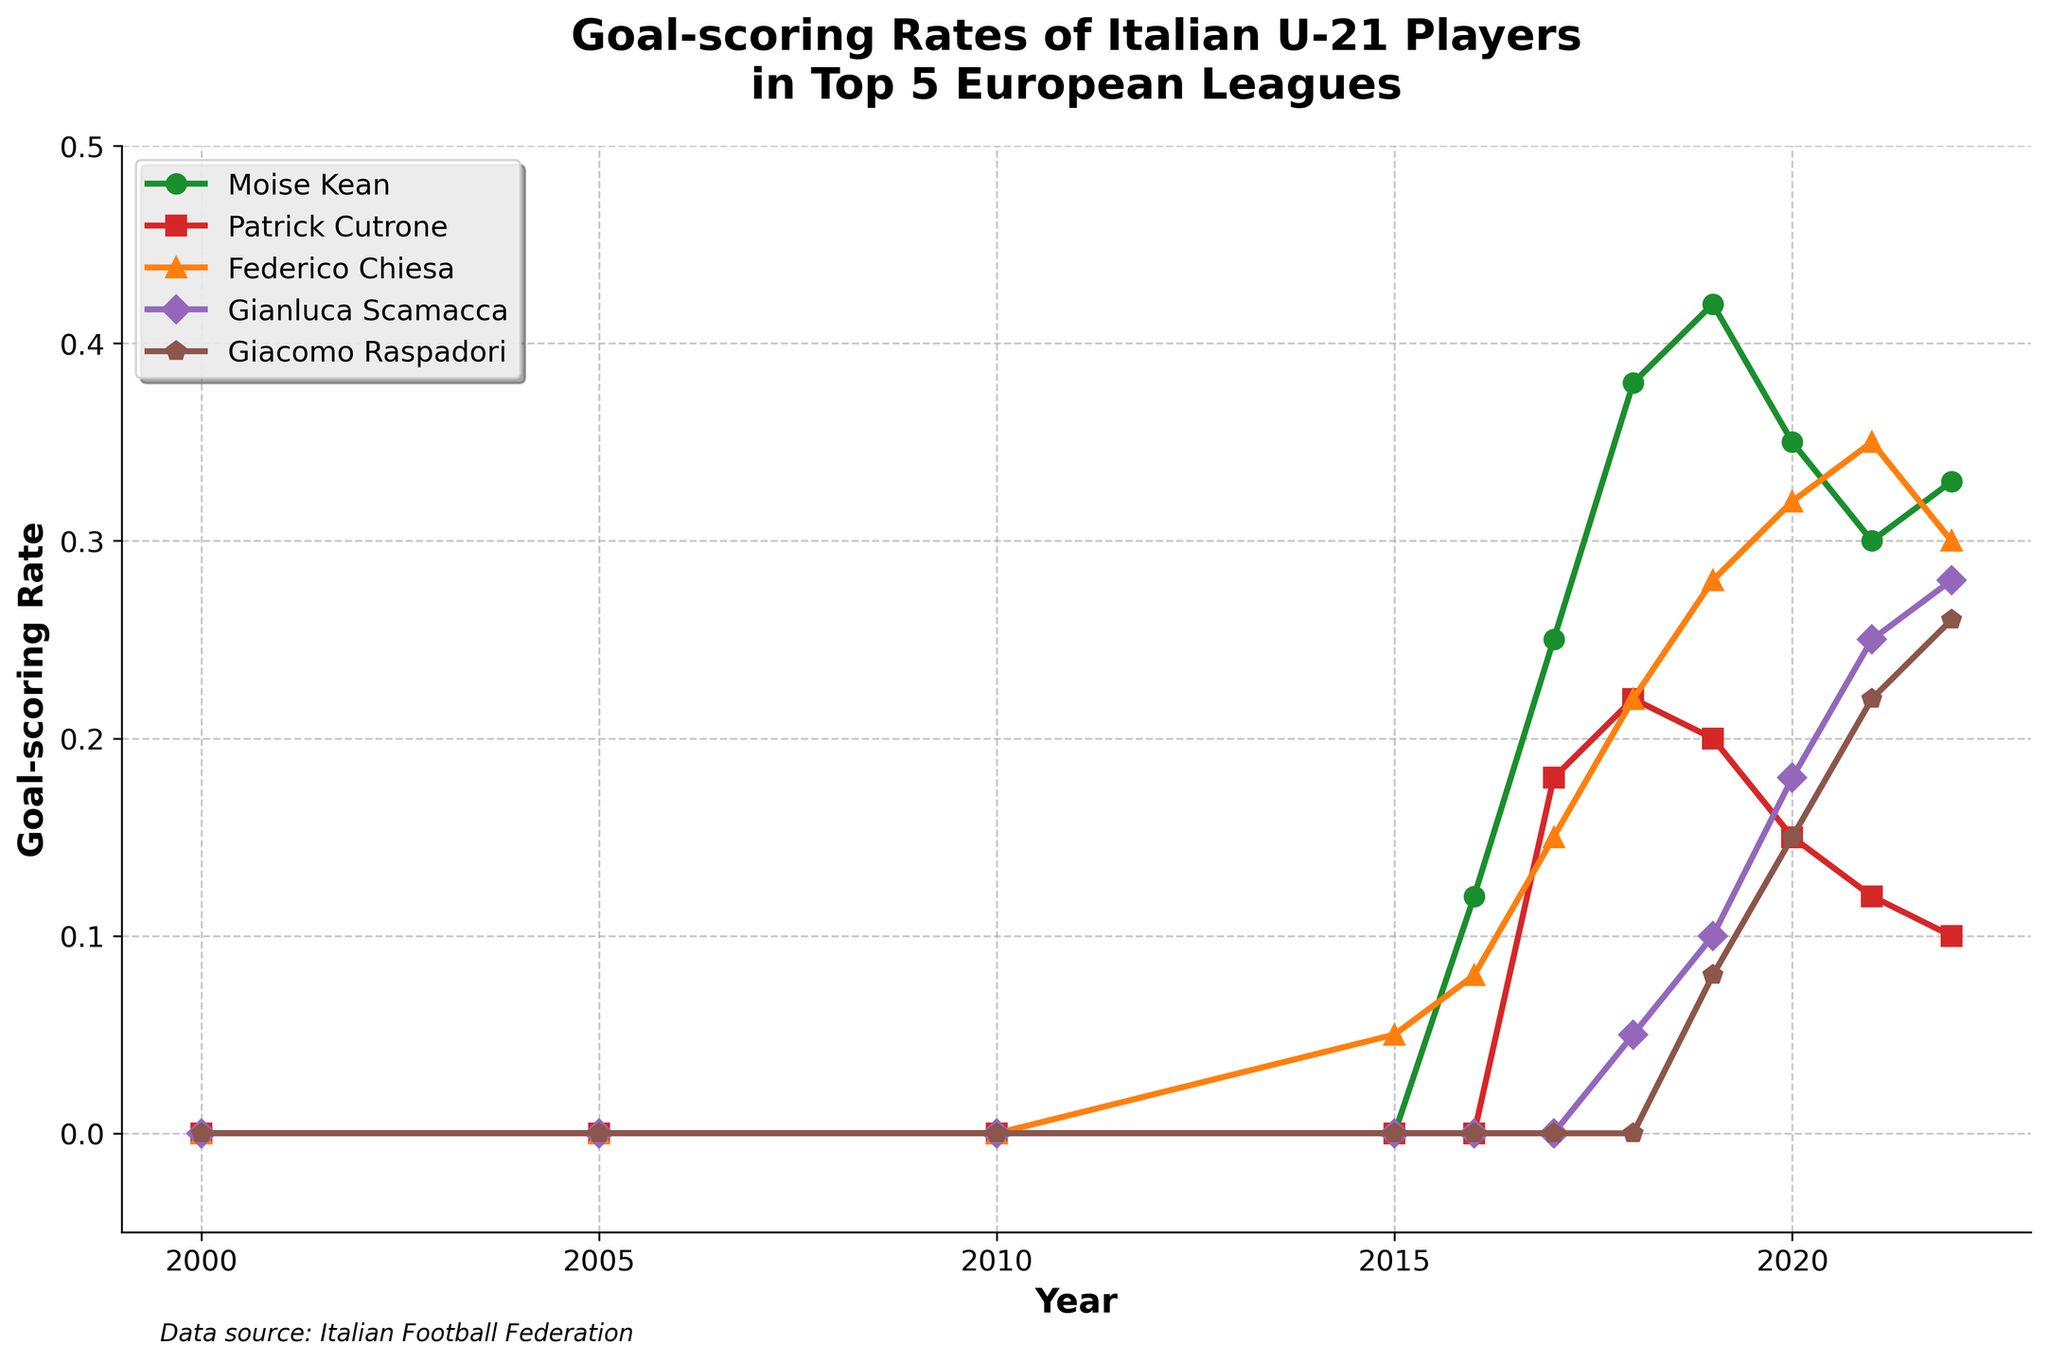What is the trend of Moise Kean's goal-scoring rate from 2016 to 2022? To find the trend, observe Moise Kean's line from 2016 to 2022. His rate increased from 0.12 in 2016 to a peak of 0.42 in 2019, then decreased to 0.30 in 2021, and slightly increased to 0.33 in 2022.
Answer: Increasing, peak, then slight decrease Who had the highest goal-scoring rate in 2021 among the players? Look at the data points on the 2021 marker for each player. Federico Chiesa has the highest goal-scoring rate at 0.35.
Answer: Federico Chiesa Did Gianluca Scamacca's goal-scoring rate ever surpass Giacomo Raspadori's? If so, when? Compare the lines of Gianluca Scamacca and Giacomo Raspadori. Scamacca's line surpasses Raspadori's first in 2018 and then every year from 2021 onwards.
Answer: Yes, in 2018 and from 2021 onward What was the difference in goal-scoring rate between Federico Chiesa and Patrick Cutrone in 2017? In 2017, Federico Chiesa's rate was 0.15, and Patrick Cutrone's rate was 0.18. The difference is 0.18 - 0.15 = 0.03.
Answer: 0.03 Did any player have a continuous increase in their goal-scoring rate from 2016 to 2022? Examine each player's line from 2016 to 2022. Continuous increase means the rate should never drop. Moise Kean and Federico Chiesa do not fit as they have drops (e.g., in 2020 for Kean). Giacomo Raspadori has a continuous increase from 2019.
Answer: Giacomo Raspadori (from 2019 to 2022) Which year did Moise Kean achieve his peak goal-scoring rate, and what was the value? To determine the peak, look at Moise Kean's rate across all years. It peaks in 2019 with a rate of 0.42.
Answer: 2019, 0.42 Whose goal-scoring rate improved the most between 2018 and 2019? Compare the differences for each player between 2018 and 2019: Kean (0.42 - 0.38 = 0.04), Cutrone (-0.02), Chiesa (0.28 - 0.22 = 0.06), Scamacca (0.05), Raspadori (0.08). Chiesa improved the most with an increase of 0.06.
Answer: Federico Chiesa Compare the goal-scoring rate of Federico Chiesa in 2020 with Patrick Cutrone in 2016. Who had a higher rate? Federico Chiesa had a rate of 0.32 in 2020, while Patrick Cutrone had 0.18 in 2016.
Answer: Federico Chiesa Which player had the most consistent goal-scoring rate (least variation) from 2016 to 2022? Consistency can be observed by identifying the player with the smallest overall changes. Federico Chiesa’s variations are: 0.08 (2016), 0.15 (2017), 0.22 (2018), 0.28 (2019), 0.32 (2020), 0.35 (2021), 0.30 (2022). Calculating the variation for all players and checking, we find Chiesa has relatively small variations.
Answer: Federico Chiesa By how much did Gianluca Scamacca's goal-scoring rate grow from 2018 to 2022? Scamacca's rate in 2018 is 0.05, and in 2022 it is 0.28. The growth is 0.28 - 0.05 = 0.23.
Answer: 0.23 